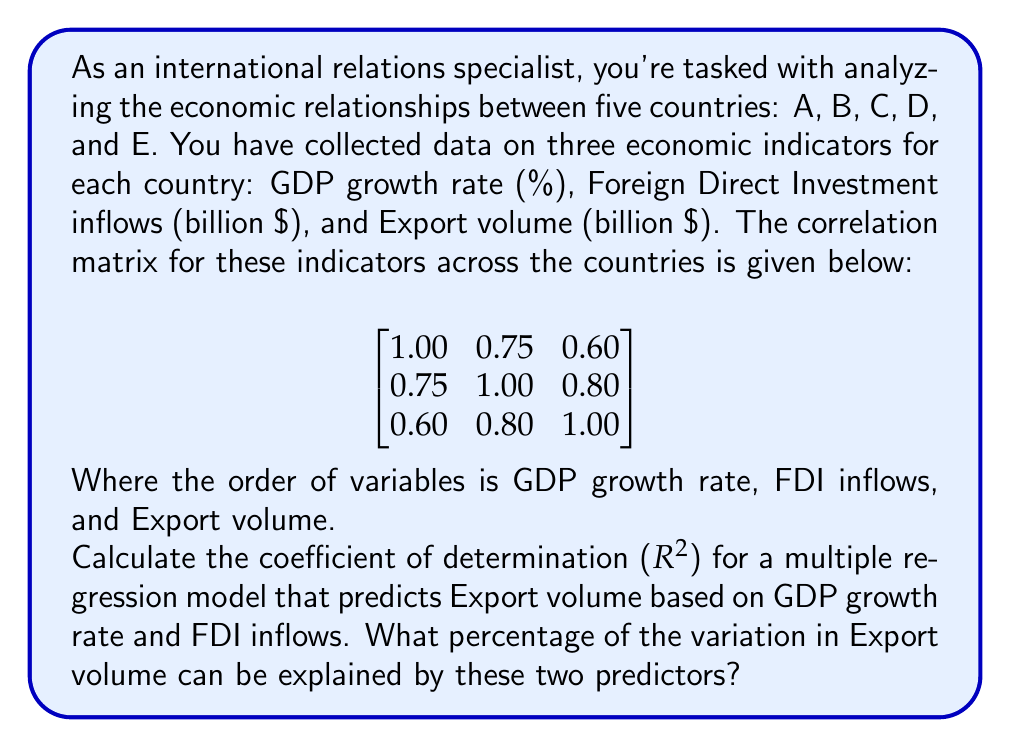What is the answer to this math problem? To solve this problem, we'll follow these steps:

1) The coefficient of determination ($R^2$) in multiple regression is equal to the square of the multiple correlation coefficient ($R$).

2) For a two-predictor model, we can calculate $R^2$ using the following formula:

   $$R^2 = \frac{r_{y1}^2 + r_{y2}^2 - 2r_{y1}r_{y2}r_{12}}{1 - r_{12}^2}$$

   Where:
   $y$ is the dependent variable (Export volume)
   $1$ and $2$ are the predictors (GDP growth rate and FDI inflows)
   $r_{y1}$, $r_{y2}$, and $r_{12}$ are the correlations between these variables

3) From the correlation matrix:
   $r_{y1} = 0.60$ (correlation between Export volume and GDP growth rate)
   $r_{y2} = 0.80$ (correlation between Export volume and FDI inflows)
   $r_{12} = 0.75$ (correlation between GDP growth rate and FDI inflows)

4) Let's substitute these values into the formula:

   $$R^2 = \frac{0.60^2 + 0.80^2 - 2(0.60)(0.80)(0.75)}{1 - 0.75^2}$$

5) Calculating:

   $$R^2 = \frac{0.36 + 0.64 - 0.72}{1 - 0.5625} = \frac{0.28}{0.4375} = 0.64$$

6) Convert to percentage: 0.64 * 100 = 64%

Therefore, 64% of the variation in Export volume can be explained by GDP growth rate and FDI inflows.
Answer: 64% 